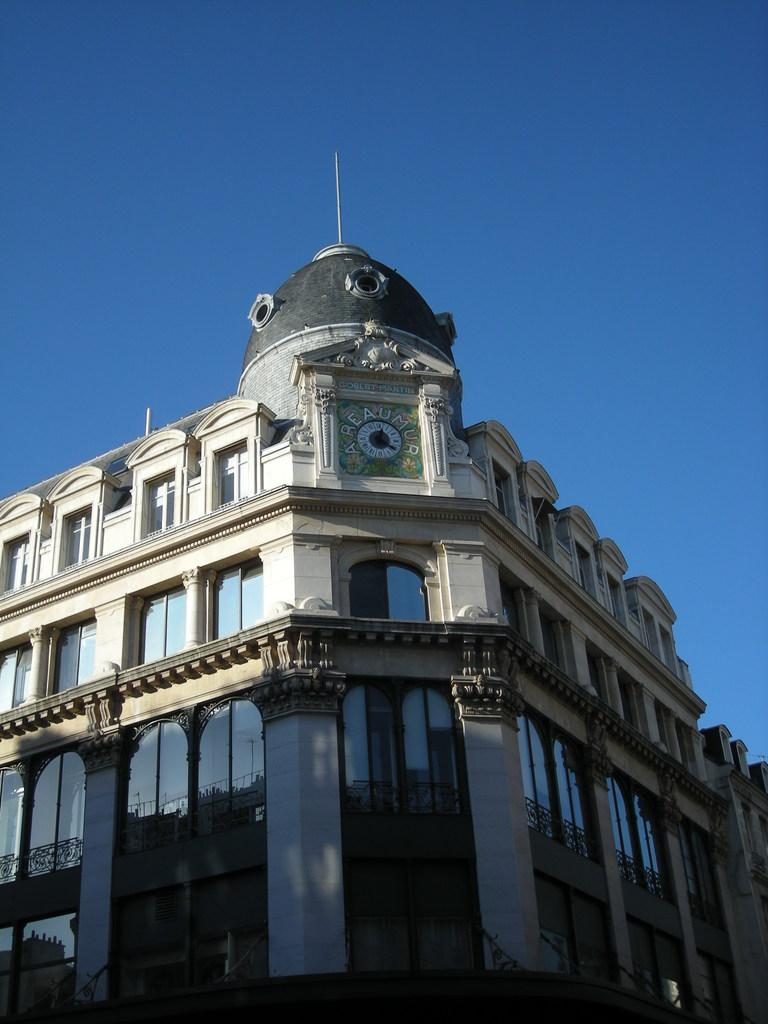What is the main structure in the image? There is a building in the image. What can be seen in the background of the image? The sky is visible in the background of the image. How does the building increase in size over time in the image? The building does not increase in size over time in the image; it is a static structure. 